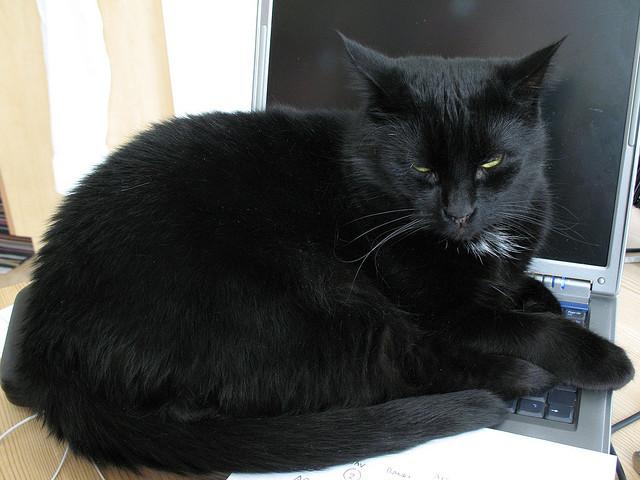What shape are the cat's eyes?
Concise answer only. Oval. Is this a kitten?
Keep it brief. No. What color is the cat?
Give a very brief answer. Black. What is the cat sitting on?
Keep it brief. Computer. Is it safe to move this cat?
Concise answer only. Yes. 